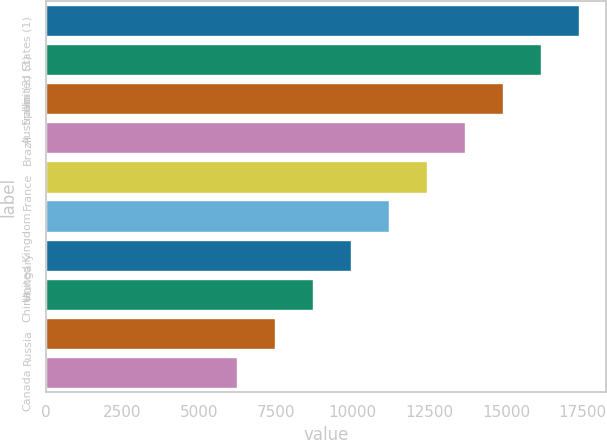Convert chart to OTSL. <chart><loc_0><loc_0><loc_500><loc_500><bar_chart><fcel>United States (1)<fcel>Spain (2) (3)<fcel>Australia<fcel>Brazil<fcel>France<fcel>United Kingdom<fcel>Hungary<fcel>China<fcel>Russia<fcel>Canada<nl><fcel>17383<fcel>16143.5<fcel>14904<fcel>13664.5<fcel>12425<fcel>11185.5<fcel>9946<fcel>8706.5<fcel>7467<fcel>6227.5<nl></chart> 